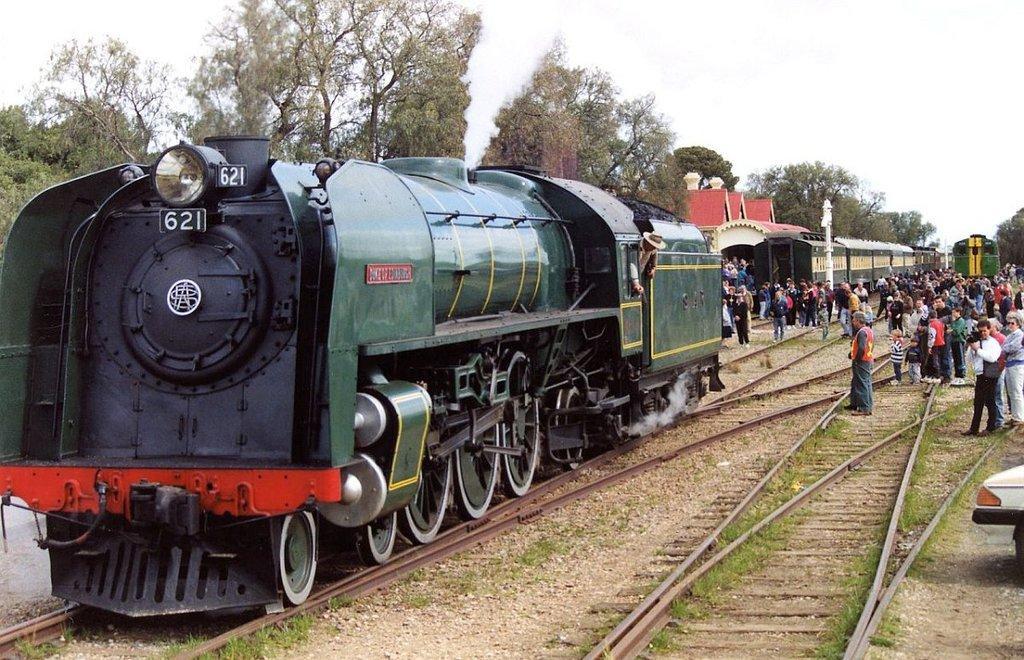How would you summarize this image in a sentence or two? In this picture I can see trains on the railway tracks, there are group of people standing, there are trees, and in the background there is the sky. 